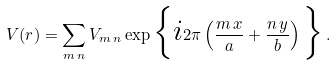<formula> <loc_0><loc_0><loc_500><loc_500>V ( r ) = \sum _ { m \, n } V _ { m \, n } \exp \Big { \{ i } 2 \pi \left ( \frac { m \, x } { a } + \frac { n \, y } { b } \right ) \Big { \} } \, .</formula> 